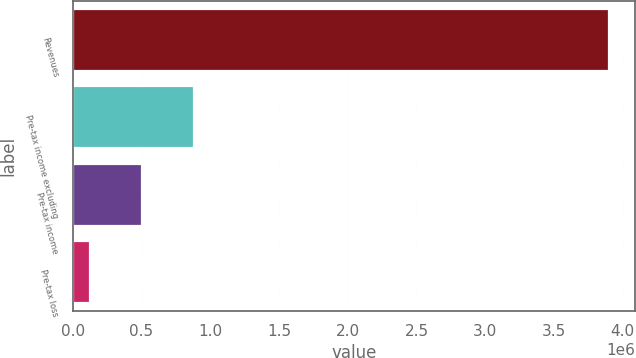Convert chart. <chart><loc_0><loc_0><loc_500><loc_500><bar_chart><fcel>Revenues<fcel>Pre-tax income excluding<fcel>Pre-tax income<fcel>Pre-tax loss<nl><fcel>3.8979e+06<fcel>880956<fcel>503838<fcel>126720<nl></chart> 